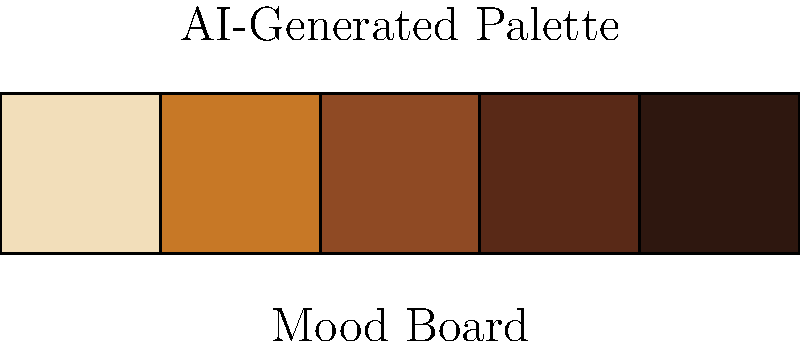Given a mood board of fashion illustrations with an autumn theme, which AI technique would be most suitable for generating a harmonious color palette, as shown in the image above? To generate a harmonious color palette from a mood board of fashion illustrations, we should consider the following steps:

1. Image Analysis: The AI should first analyze the mood board images to extract dominant colors and color relationships.

2. Color Quantization: Reduce the number of colors in the image to a manageable set, typically using algorithms like K-means clustering.

3. Color Harmony Rules: Apply color theory principles such as complementary, analogous, or triadic color schemes to ensure harmony.

4. Contextual Understanding: The AI should recognize the autumn theme and adjust the palette accordingly, favoring warm, earthy tones.

5. Machine Learning Model: Use a trained model, such as a Generative Adversarial Network (GAN) or a Variational Autoencoder (VAE), to generate new color combinations based on the input.

6. Fine-tuning: Adjust the generated palette to ensure it meets specific criteria for fashion design, such as contrast and versatility.

Given these requirements, the most suitable AI technique for this task would be a Generative Adversarial Network (GAN) specialized in color palette generation. GANs can learn complex color relationships and generate new, harmonious color combinations that capture the essence of the input mood board while introducing creative variations.
Answer: Generative Adversarial Network (GAN) 